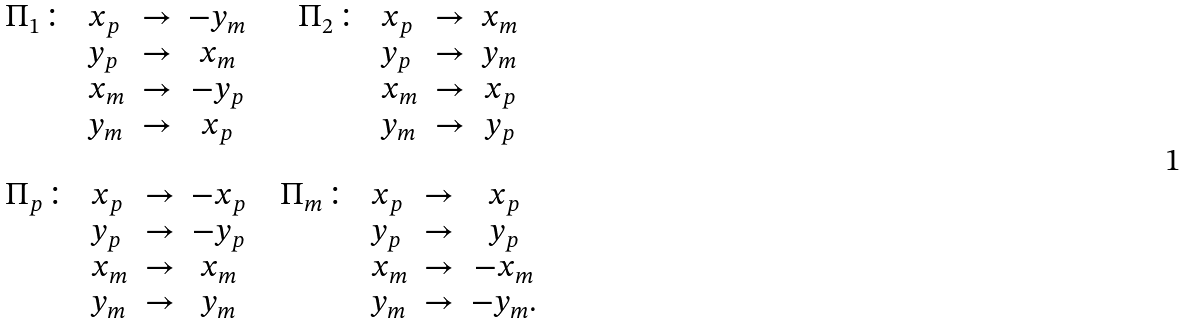<formula> <loc_0><loc_0><loc_500><loc_500>\begin{array} { c c } \begin{array} { l l c c } \Pi _ { 1 } \colon & x _ { p } & \rightarrow & - y _ { m } \\ & y _ { p } & \rightarrow & x _ { m } \\ & x _ { m } & \rightarrow & - y _ { p } \\ & y _ { m } & \rightarrow & x _ { p } \end{array} & \begin{array} { l l c c } \Pi _ { 2 } \colon & x _ { p } & \rightarrow & x _ { m } \\ & y _ { p } & \rightarrow & y _ { m } \\ & x _ { m } & \rightarrow & x _ { p } \\ & y _ { m } & \rightarrow & y _ { p } \end{array} \\ \\ \begin{array} { l l c c } \Pi _ { p } \colon & x _ { p } & \rightarrow & - x _ { p } \\ & y _ { p } & \rightarrow & - y _ { p } \\ & x _ { m } & \rightarrow & x _ { m } \\ & y _ { m } & \rightarrow & y _ { m } \end{array} & \begin{array} { l l c c } \Pi _ { m } \colon & x _ { p } & \rightarrow & x _ { p } \\ & y _ { p } & \rightarrow & y _ { p } \\ & x _ { m } & \rightarrow & - x _ { m } \\ & y _ { m } & \rightarrow & - y _ { m } . \end{array} \end{array}</formula> 